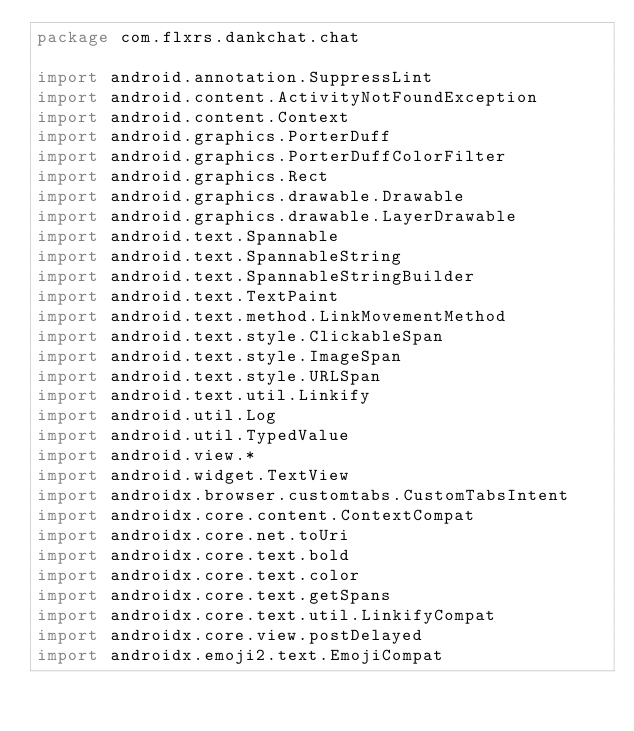Convert code to text. <code><loc_0><loc_0><loc_500><loc_500><_Kotlin_>package com.flxrs.dankchat.chat

import android.annotation.SuppressLint
import android.content.ActivityNotFoundException
import android.content.Context
import android.graphics.PorterDuff
import android.graphics.PorterDuffColorFilter
import android.graphics.Rect
import android.graphics.drawable.Drawable
import android.graphics.drawable.LayerDrawable
import android.text.Spannable
import android.text.SpannableString
import android.text.SpannableStringBuilder
import android.text.TextPaint
import android.text.method.LinkMovementMethod
import android.text.style.ClickableSpan
import android.text.style.ImageSpan
import android.text.style.URLSpan
import android.text.util.Linkify
import android.util.Log
import android.util.TypedValue
import android.view.*
import android.widget.TextView
import androidx.browser.customtabs.CustomTabsIntent
import androidx.core.content.ContextCompat
import androidx.core.net.toUri
import androidx.core.text.bold
import androidx.core.text.color
import androidx.core.text.getSpans
import androidx.core.text.util.LinkifyCompat
import androidx.core.view.postDelayed
import androidx.emoji2.text.EmojiCompat</code> 